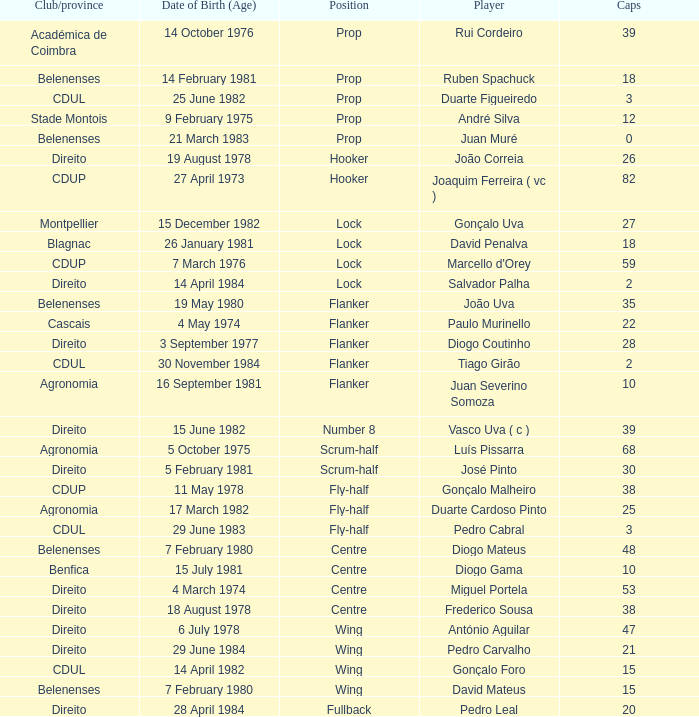Which player has a Club/province of direito, less than 21 caps, and a Position of lock? Salvador Palha. 